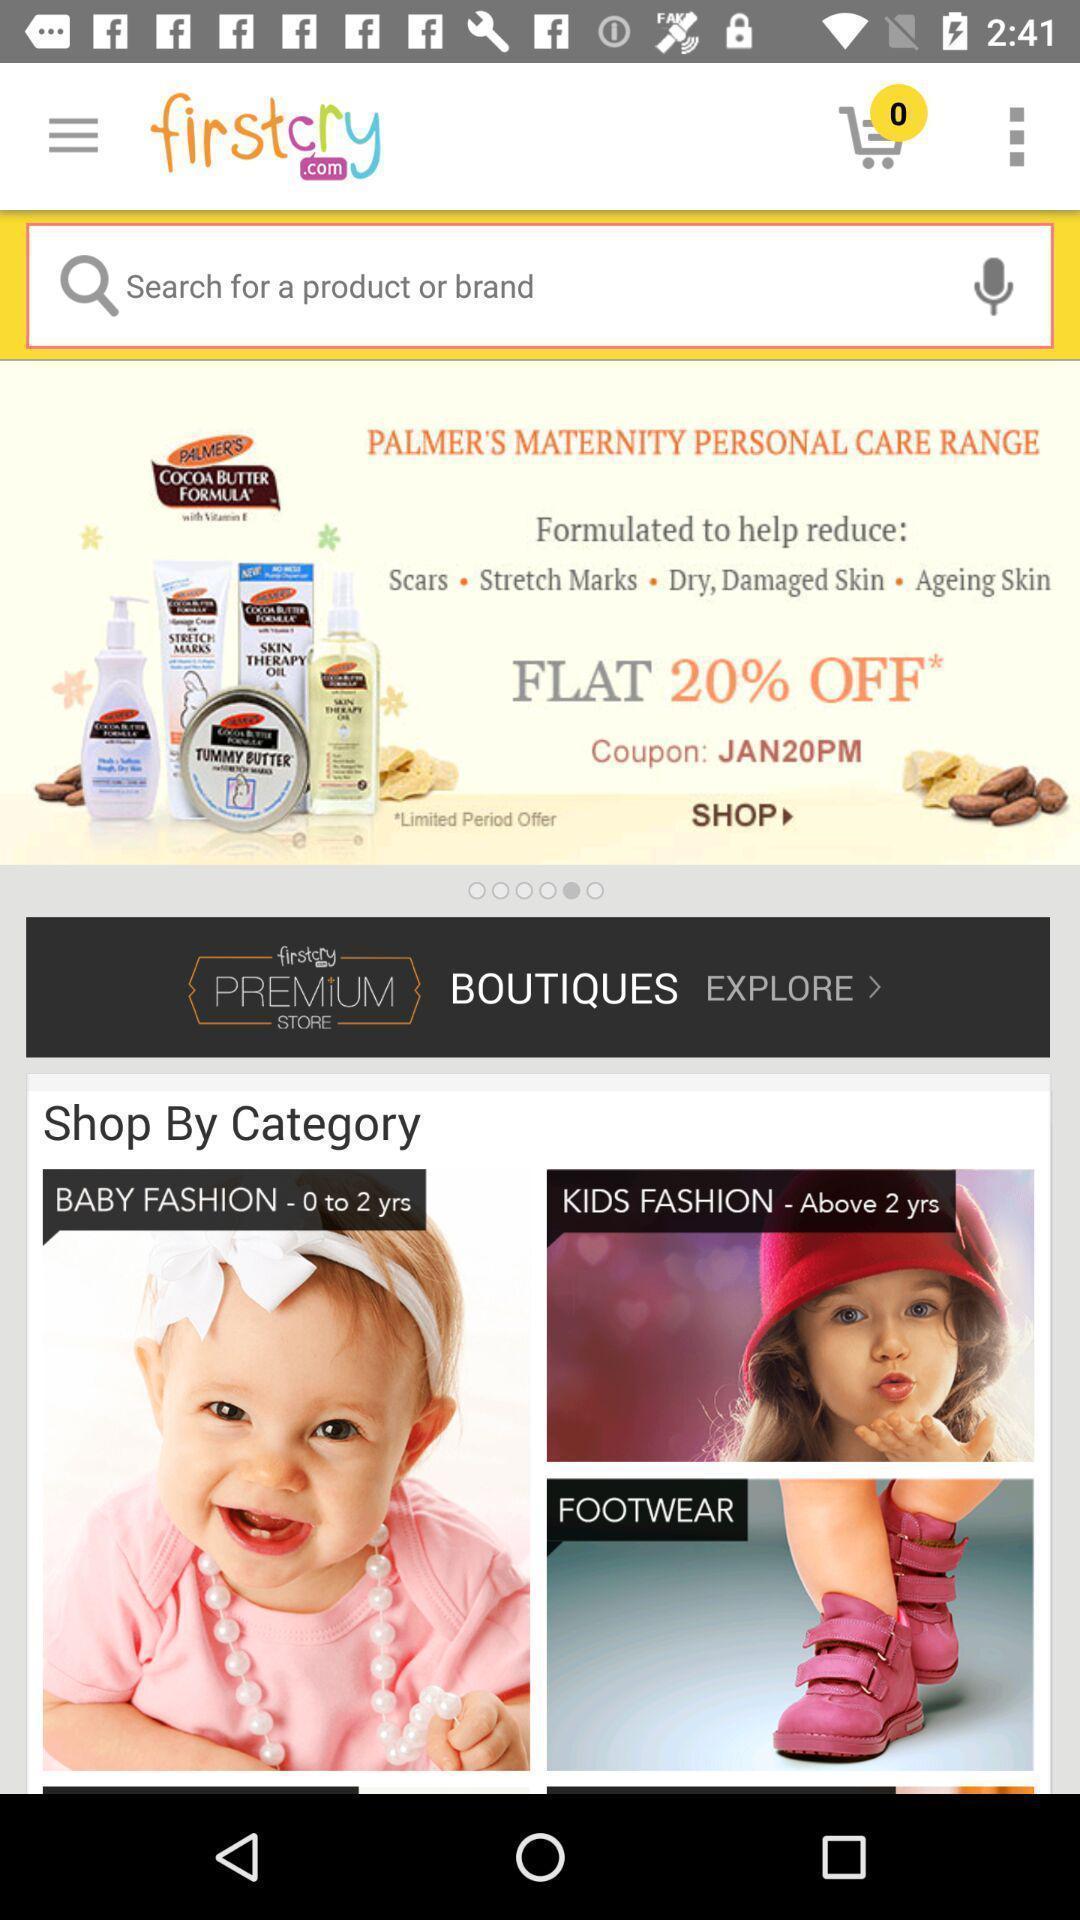Describe the visual elements of this screenshot. Search page of a kids app. 